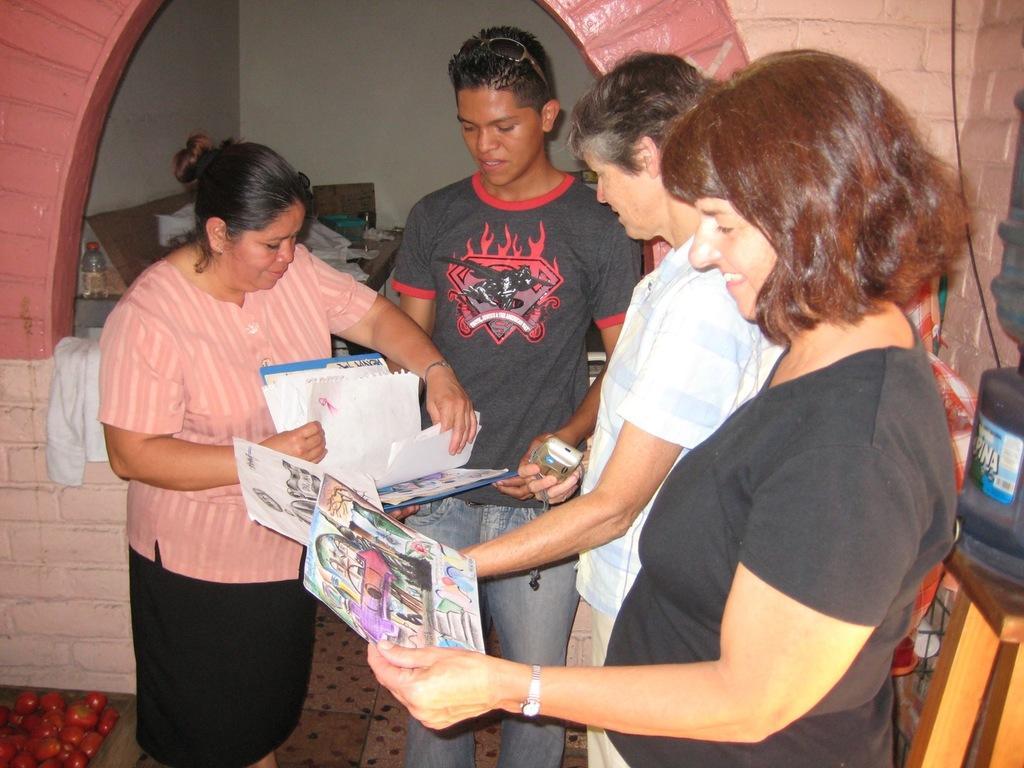Can you describe this image briefly? In this image we can see some people holding the papers. A person is holding an object. There are two other persons holding a file. Behind the people there is a bottle and some objects. On the right side of the image there is a water can on the table. At the bottom left side of the image there are tomatoes. 